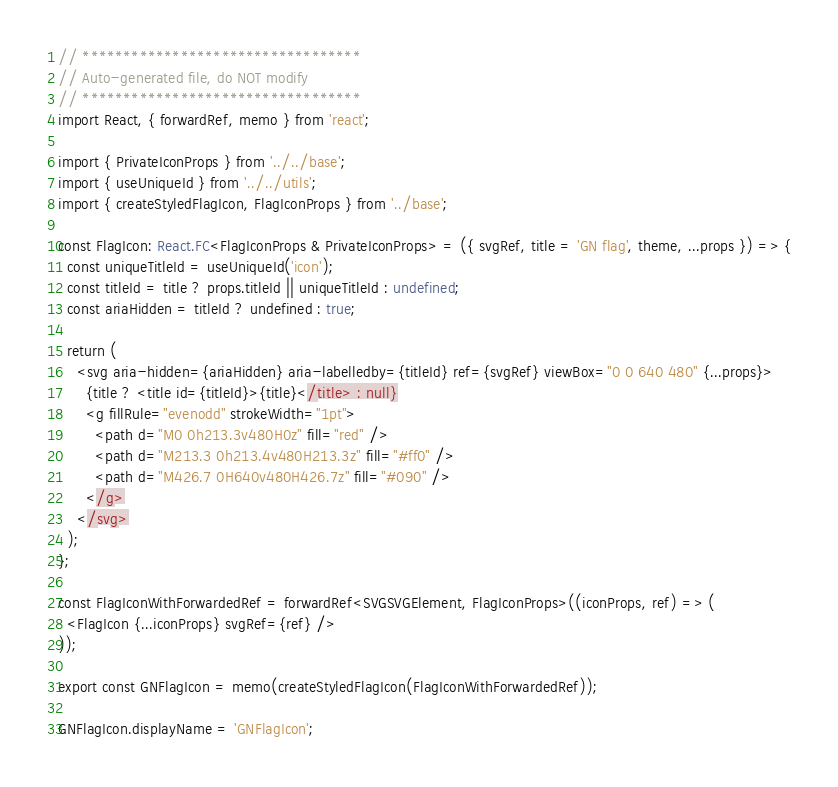<code> <loc_0><loc_0><loc_500><loc_500><_TypeScript_>// **********************************
// Auto-generated file, do NOT modify
// **********************************
import React, { forwardRef, memo } from 'react';

import { PrivateIconProps } from '../../base';
import { useUniqueId } from '../../utils';
import { createStyledFlagIcon, FlagIconProps } from '../base';

const FlagIcon: React.FC<FlagIconProps & PrivateIconProps> = ({ svgRef, title = 'GN flag', theme, ...props }) => {
  const uniqueTitleId = useUniqueId('icon');
  const titleId = title ? props.titleId || uniqueTitleId : undefined;
  const ariaHidden = titleId ? undefined : true;

  return (
    <svg aria-hidden={ariaHidden} aria-labelledby={titleId} ref={svgRef} viewBox="0 0 640 480" {...props}>
      {title ? <title id={titleId}>{title}</title> : null}
      <g fillRule="evenodd" strokeWidth="1pt">
        <path d="M0 0h213.3v480H0z" fill="red" />
        <path d="M213.3 0h213.4v480H213.3z" fill="#ff0" />
        <path d="M426.7 0H640v480H426.7z" fill="#090" />
      </g>
    </svg>
  );
};

const FlagIconWithForwardedRef = forwardRef<SVGSVGElement, FlagIconProps>((iconProps, ref) => (
  <FlagIcon {...iconProps} svgRef={ref} />
));

export const GNFlagIcon = memo(createStyledFlagIcon(FlagIconWithForwardedRef));

GNFlagIcon.displayName = 'GNFlagIcon';
</code> 